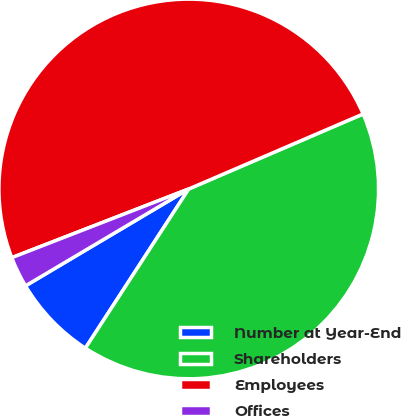Convert chart. <chart><loc_0><loc_0><loc_500><loc_500><pie_chart><fcel>Number at Year-End<fcel>Shareholders<fcel>Employees<fcel>Offices<nl><fcel>7.31%<fcel>40.63%<fcel>49.43%<fcel>2.63%<nl></chart> 